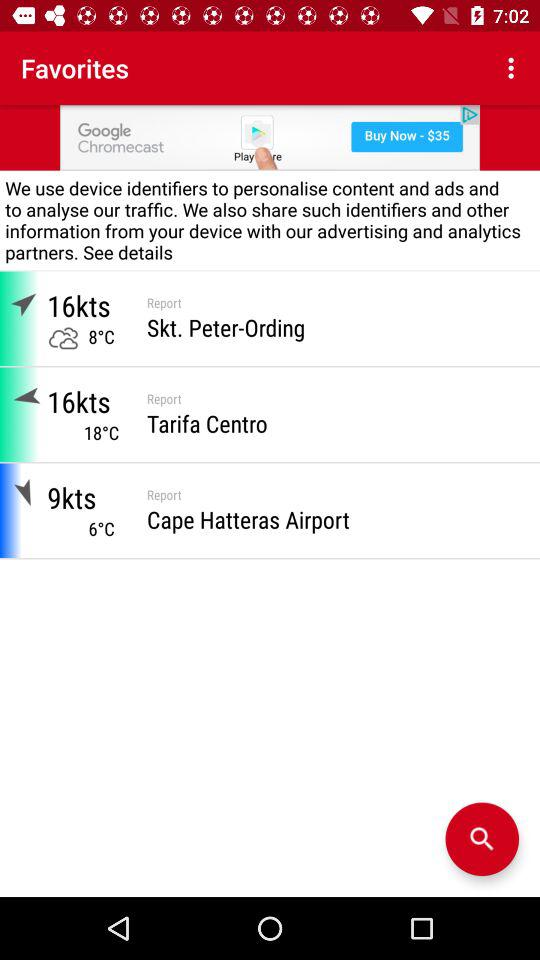What is the wind speed in Tarifa Centro? The wind speed in Tarifa Centro is 16 knots. 